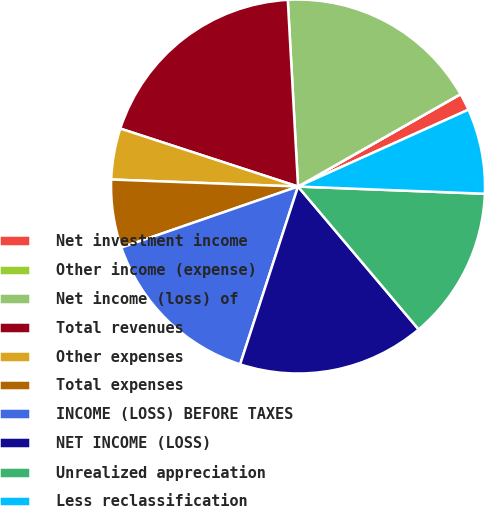Convert chart. <chart><loc_0><loc_0><loc_500><loc_500><pie_chart><fcel>Net investment income<fcel>Other income (expense)<fcel>Net income (loss) of<fcel>Total revenues<fcel>Other expenses<fcel>Total expenses<fcel>INCOME (LOSS) BEFORE TAXES<fcel>NET INCOME (LOSS)<fcel>Unrealized appreciation<fcel>Less reclassification<nl><fcel>1.48%<fcel>0.01%<fcel>17.64%<fcel>19.11%<fcel>4.42%<fcel>5.89%<fcel>14.7%<fcel>16.17%<fcel>13.23%<fcel>7.36%<nl></chart> 